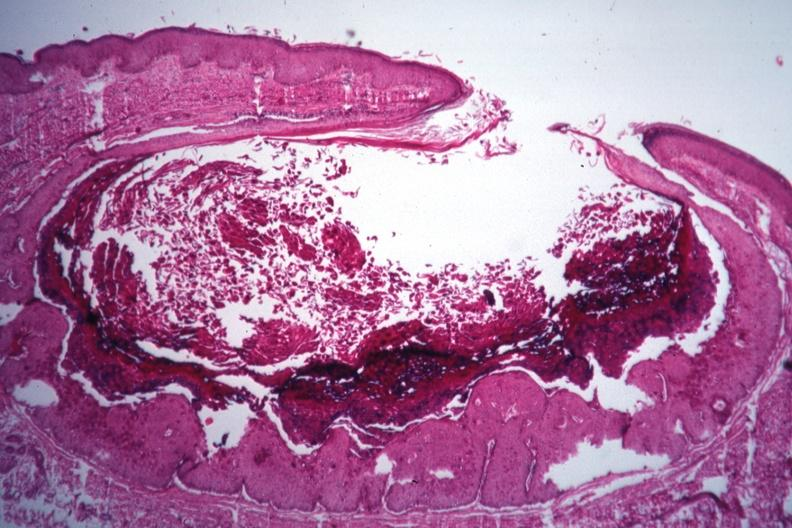what is present?
Answer the question using a single word or phrase. Molluscum contagiosum 